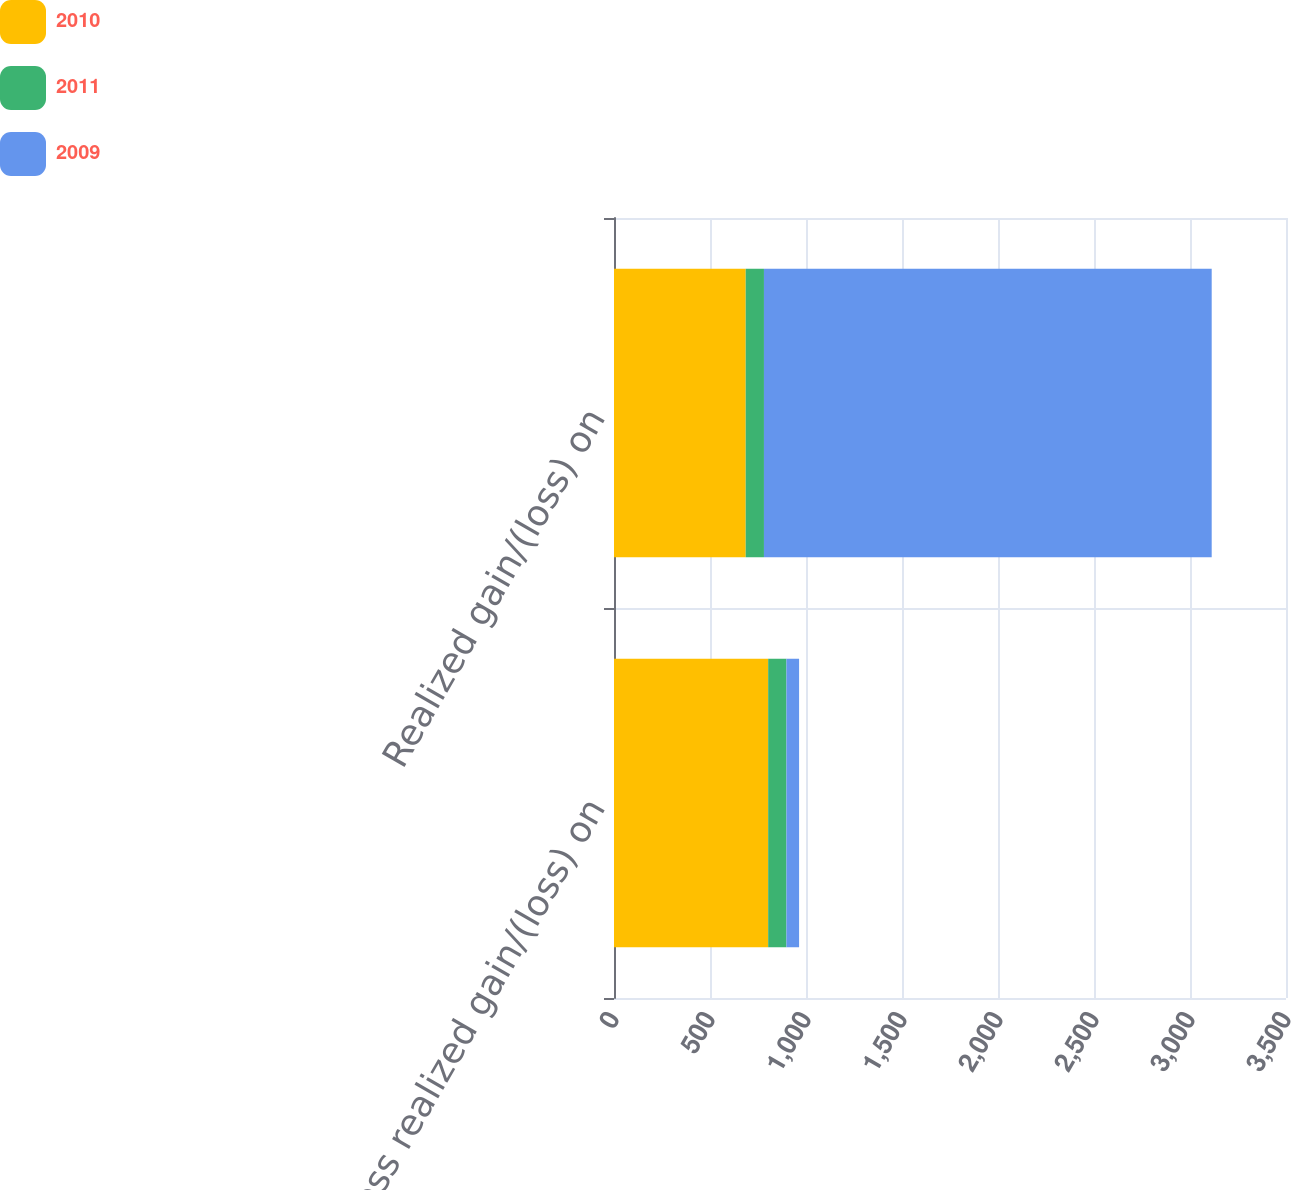Convert chart to OTSL. <chart><loc_0><loc_0><loc_500><loc_500><stacked_bar_chart><ecel><fcel>Gross realized gain/(loss) on<fcel>Realized gain/(loss) on<nl><fcel>2010<fcel>803<fcel>686<nl><fcel>2011<fcel>95<fcel>95<nl><fcel>2009<fcel>66<fcel>2332<nl></chart> 